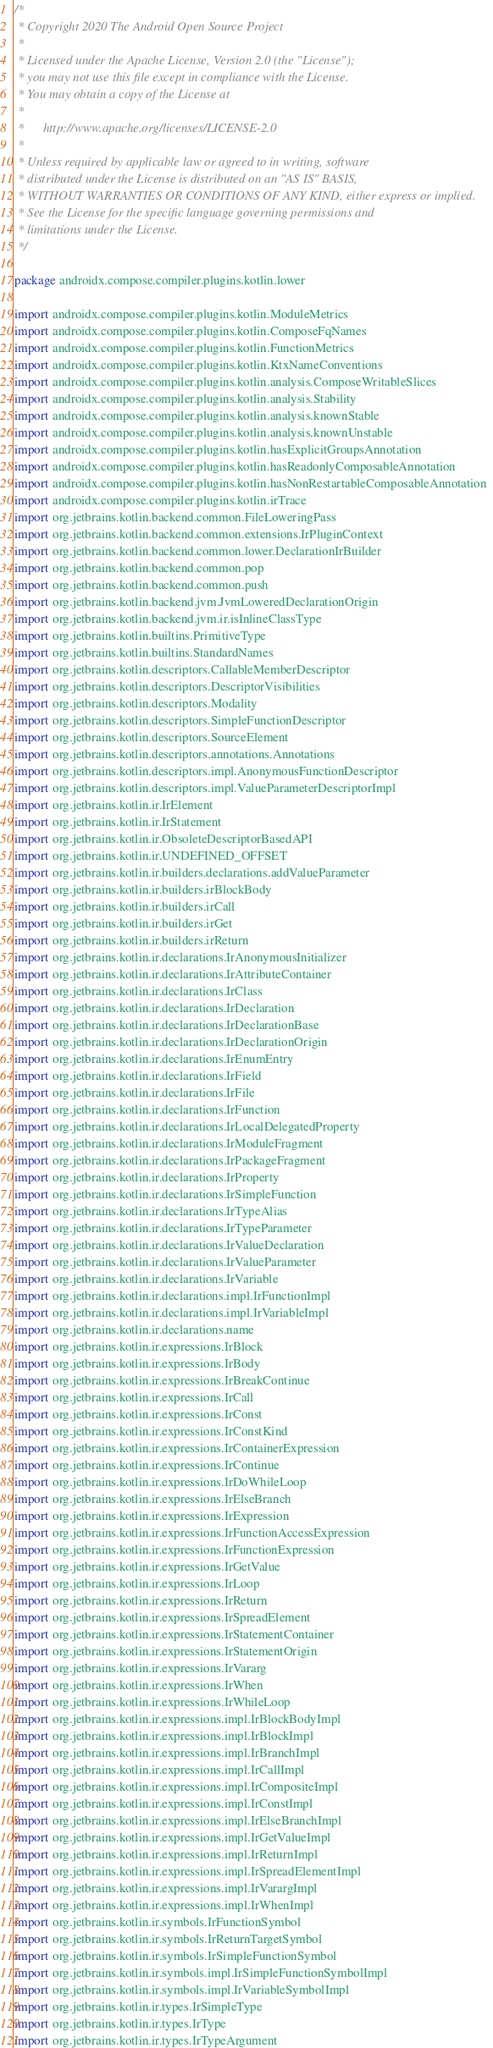<code> <loc_0><loc_0><loc_500><loc_500><_Kotlin_>/*
 * Copyright 2020 The Android Open Source Project
 *
 * Licensed under the Apache License, Version 2.0 (the "License");
 * you may not use this file except in compliance with the License.
 * You may obtain a copy of the License at
 *
 *      http://www.apache.org/licenses/LICENSE-2.0
 *
 * Unless required by applicable law or agreed to in writing, software
 * distributed under the License is distributed on an "AS IS" BASIS,
 * WITHOUT WARRANTIES OR CONDITIONS OF ANY KIND, either express or implied.
 * See the License for the specific language governing permissions and
 * limitations under the License.
 */

package androidx.compose.compiler.plugins.kotlin.lower

import androidx.compose.compiler.plugins.kotlin.ModuleMetrics
import androidx.compose.compiler.plugins.kotlin.ComposeFqNames
import androidx.compose.compiler.plugins.kotlin.FunctionMetrics
import androidx.compose.compiler.plugins.kotlin.KtxNameConventions
import androidx.compose.compiler.plugins.kotlin.analysis.ComposeWritableSlices
import androidx.compose.compiler.plugins.kotlin.analysis.Stability
import androidx.compose.compiler.plugins.kotlin.analysis.knownStable
import androidx.compose.compiler.plugins.kotlin.analysis.knownUnstable
import androidx.compose.compiler.plugins.kotlin.hasExplicitGroupsAnnotation
import androidx.compose.compiler.plugins.kotlin.hasReadonlyComposableAnnotation
import androidx.compose.compiler.plugins.kotlin.hasNonRestartableComposableAnnotation
import androidx.compose.compiler.plugins.kotlin.irTrace
import org.jetbrains.kotlin.backend.common.FileLoweringPass
import org.jetbrains.kotlin.backend.common.extensions.IrPluginContext
import org.jetbrains.kotlin.backend.common.lower.DeclarationIrBuilder
import org.jetbrains.kotlin.backend.common.pop
import org.jetbrains.kotlin.backend.common.push
import org.jetbrains.kotlin.backend.jvm.JvmLoweredDeclarationOrigin
import org.jetbrains.kotlin.backend.jvm.ir.isInlineClassType
import org.jetbrains.kotlin.builtins.PrimitiveType
import org.jetbrains.kotlin.builtins.StandardNames
import org.jetbrains.kotlin.descriptors.CallableMemberDescriptor
import org.jetbrains.kotlin.descriptors.DescriptorVisibilities
import org.jetbrains.kotlin.descriptors.Modality
import org.jetbrains.kotlin.descriptors.SimpleFunctionDescriptor
import org.jetbrains.kotlin.descriptors.SourceElement
import org.jetbrains.kotlin.descriptors.annotations.Annotations
import org.jetbrains.kotlin.descriptors.impl.AnonymousFunctionDescriptor
import org.jetbrains.kotlin.descriptors.impl.ValueParameterDescriptorImpl
import org.jetbrains.kotlin.ir.IrElement
import org.jetbrains.kotlin.ir.IrStatement
import org.jetbrains.kotlin.ir.ObsoleteDescriptorBasedAPI
import org.jetbrains.kotlin.ir.UNDEFINED_OFFSET
import org.jetbrains.kotlin.ir.builders.declarations.addValueParameter
import org.jetbrains.kotlin.ir.builders.irBlockBody
import org.jetbrains.kotlin.ir.builders.irCall
import org.jetbrains.kotlin.ir.builders.irGet
import org.jetbrains.kotlin.ir.builders.irReturn
import org.jetbrains.kotlin.ir.declarations.IrAnonymousInitializer
import org.jetbrains.kotlin.ir.declarations.IrAttributeContainer
import org.jetbrains.kotlin.ir.declarations.IrClass
import org.jetbrains.kotlin.ir.declarations.IrDeclaration
import org.jetbrains.kotlin.ir.declarations.IrDeclarationBase
import org.jetbrains.kotlin.ir.declarations.IrDeclarationOrigin
import org.jetbrains.kotlin.ir.declarations.IrEnumEntry
import org.jetbrains.kotlin.ir.declarations.IrField
import org.jetbrains.kotlin.ir.declarations.IrFile
import org.jetbrains.kotlin.ir.declarations.IrFunction
import org.jetbrains.kotlin.ir.declarations.IrLocalDelegatedProperty
import org.jetbrains.kotlin.ir.declarations.IrModuleFragment
import org.jetbrains.kotlin.ir.declarations.IrPackageFragment
import org.jetbrains.kotlin.ir.declarations.IrProperty
import org.jetbrains.kotlin.ir.declarations.IrSimpleFunction
import org.jetbrains.kotlin.ir.declarations.IrTypeAlias
import org.jetbrains.kotlin.ir.declarations.IrTypeParameter
import org.jetbrains.kotlin.ir.declarations.IrValueDeclaration
import org.jetbrains.kotlin.ir.declarations.IrValueParameter
import org.jetbrains.kotlin.ir.declarations.IrVariable
import org.jetbrains.kotlin.ir.declarations.impl.IrFunctionImpl
import org.jetbrains.kotlin.ir.declarations.impl.IrVariableImpl
import org.jetbrains.kotlin.ir.declarations.name
import org.jetbrains.kotlin.ir.expressions.IrBlock
import org.jetbrains.kotlin.ir.expressions.IrBody
import org.jetbrains.kotlin.ir.expressions.IrBreakContinue
import org.jetbrains.kotlin.ir.expressions.IrCall
import org.jetbrains.kotlin.ir.expressions.IrConst
import org.jetbrains.kotlin.ir.expressions.IrConstKind
import org.jetbrains.kotlin.ir.expressions.IrContainerExpression
import org.jetbrains.kotlin.ir.expressions.IrContinue
import org.jetbrains.kotlin.ir.expressions.IrDoWhileLoop
import org.jetbrains.kotlin.ir.expressions.IrElseBranch
import org.jetbrains.kotlin.ir.expressions.IrExpression
import org.jetbrains.kotlin.ir.expressions.IrFunctionAccessExpression
import org.jetbrains.kotlin.ir.expressions.IrFunctionExpression
import org.jetbrains.kotlin.ir.expressions.IrGetValue
import org.jetbrains.kotlin.ir.expressions.IrLoop
import org.jetbrains.kotlin.ir.expressions.IrReturn
import org.jetbrains.kotlin.ir.expressions.IrSpreadElement
import org.jetbrains.kotlin.ir.expressions.IrStatementContainer
import org.jetbrains.kotlin.ir.expressions.IrStatementOrigin
import org.jetbrains.kotlin.ir.expressions.IrVararg
import org.jetbrains.kotlin.ir.expressions.IrWhen
import org.jetbrains.kotlin.ir.expressions.IrWhileLoop
import org.jetbrains.kotlin.ir.expressions.impl.IrBlockBodyImpl
import org.jetbrains.kotlin.ir.expressions.impl.IrBlockImpl
import org.jetbrains.kotlin.ir.expressions.impl.IrBranchImpl
import org.jetbrains.kotlin.ir.expressions.impl.IrCallImpl
import org.jetbrains.kotlin.ir.expressions.impl.IrCompositeImpl
import org.jetbrains.kotlin.ir.expressions.impl.IrConstImpl
import org.jetbrains.kotlin.ir.expressions.impl.IrElseBranchImpl
import org.jetbrains.kotlin.ir.expressions.impl.IrGetValueImpl
import org.jetbrains.kotlin.ir.expressions.impl.IrReturnImpl
import org.jetbrains.kotlin.ir.expressions.impl.IrSpreadElementImpl
import org.jetbrains.kotlin.ir.expressions.impl.IrVarargImpl
import org.jetbrains.kotlin.ir.expressions.impl.IrWhenImpl
import org.jetbrains.kotlin.ir.symbols.IrFunctionSymbol
import org.jetbrains.kotlin.ir.symbols.IrReturnTargetSymbol
import org.jetbrains.kotlin.ir.symbols.IrSimpleFunctionSymbol
import org.jetbrains.kotlin.ir.symbols.impl.IrSimpleFunctionSymbolImpl
import org.jetbrains.kotlin.ir.symbols.impl.IrVariableSymbolImpl
import org.jetbrains.kotlin.ir.types.IrSimpleType
import org.jetbrains.kotlin.ir.types.IrType
import org.jetbrains.kotlin.ir.types.IrTypeArgument</code> 